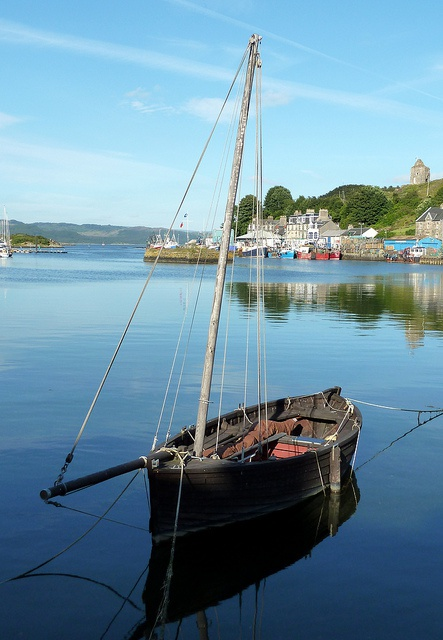Describe the objects in this image and their specific colors. I can see boat in lightblue, black, gray, and darkgray tones, boat in lightblue, lightgray, darkgray, and gray tones, boat in lightblue, darkgray, lightgray, and gray tones, boat in lightblue, white, gray, darkgray, and salmon tones, and boat in lightblue, darkgray, gray, and white tones in this image. 